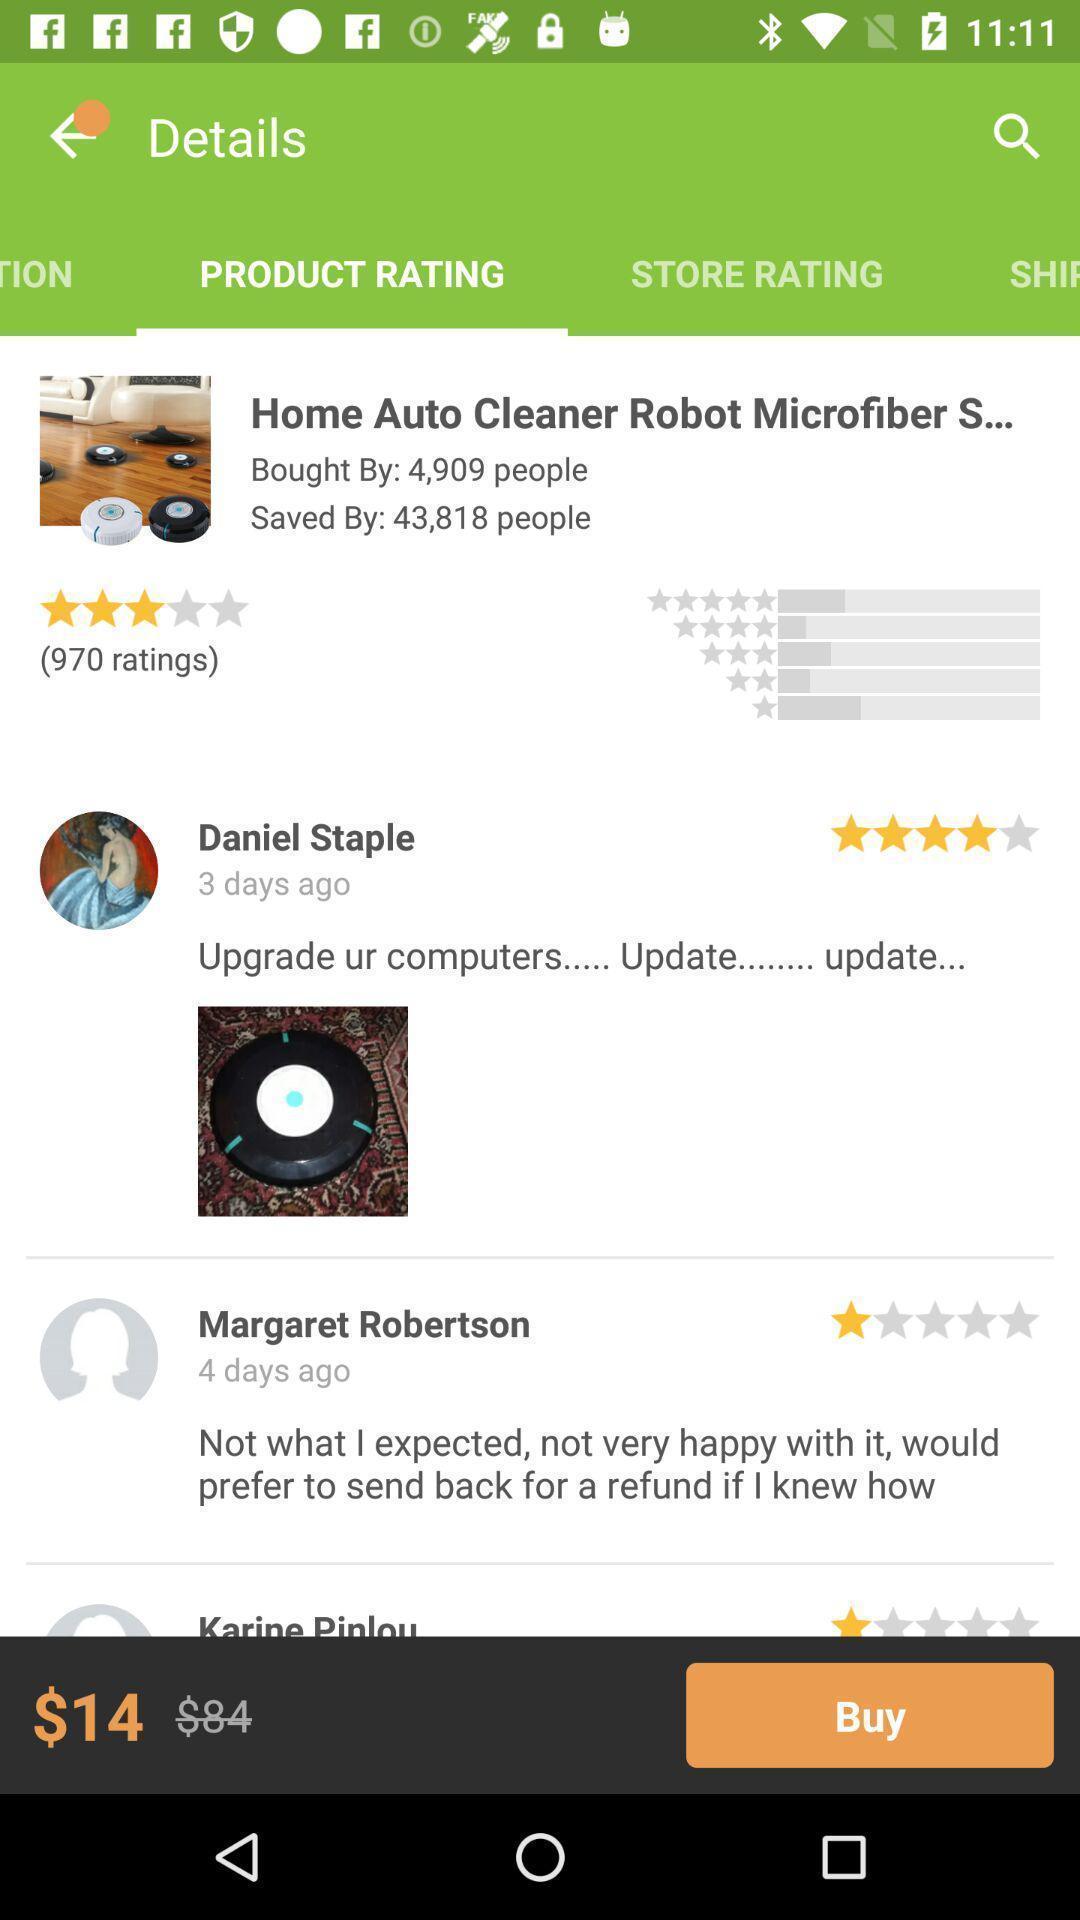Tell me what you see in this picture. Trending products rating displaying in this page. 